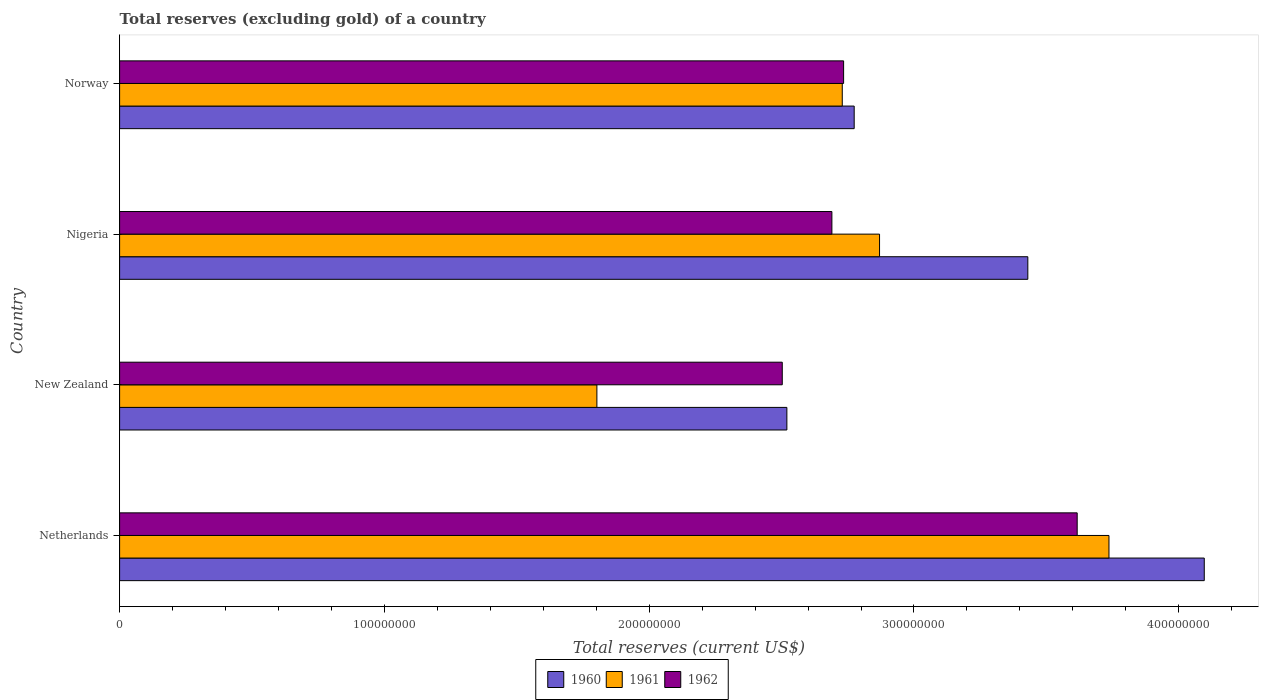How many different coloured bars are there?
Provide a short and direct response. 3. Are the number of bars per tick equal to the number of legend labels?
Ensure brevity in your answer.  Yes. How many bars are there on the 1st tick from the top?
Your response must be concise. 3. What is the label of the 3rd group of bars from the top?
Offer a terse response. New Zealand. In how many cases, is the number of bars for a given country not equal to the number of legend labels?
Make the answer very short. 0. What is the total reserves (excluding gold) in 1960 in New Zealand?
Ensure brevity in your answer.  2.52e+08. Across all countries, what is the maximum total reserves (excluding gold) in 1961?
Provide a short and direct response. 3.74e+08. Across all countries, what is the minimum total reserves (excluding gold) in 1960?
Your answer should be compact. 2.52e+08. In which country was the total reserves (excluding gold) in 1962 maximum?
Your response must be concise. Netherlands. In which country was the total reserves (excluding gold) in 1960 minimum?
Give a very brief answer. New Zealand. What is the total total reserves (excluding gold) in 1960 in the graph?
Your answer should be very brief. 1.28e+09. What is the difference between the total reserves (excluding gold) in 1962 in Netherlands and that in Norway?
Give a very brief answer. 8.82e+07. What is the difference between the total reserves (excluding gold) in 1961 in New Zealand and the total reserves (excluding gold) in 1962 in Netherlands?
Ensure brevity in your answer.  -1.81e+08. What is the average total reserves (excluding gold) in 1960 per country?
Provide a succinct answer. 3.21e+08. What is the difference between the total reserves (excluding gold) in 1960 and total reserves (excluding gold) in 1962 in Norway?
Make the answer very short. 3.99e+06. In how many countries, is the total reserves (excluding gold) in 1962 greater than 360000000 US$?
Your response must be concise. 1. What is the ratio of the total reserves (excluding gold) in 1961 in Netherlands to that in Norway?
Give a very brief answer. 1.37. Is the total reserves (excluding gold) in 1961 in Nigeria less than that in Norway?
Your answer should be very brief. No. Is the difference between the total reserves (excluding gold) in 1960 in Nigeria and Norway greater than the difference between the total reserves (excluding gold) in 1962 in Nigeria and Norway?
Make the answer very short. Yes. What is the difference between the highest and the second highest total reserves (excluding gold) in 1960?
Offer a very short reply. 6.66e+07. What is the difference between the highest and the lowest total reserves (excluding gold) in 1961?
Provide a succinct answer. 1.93e+08. How many countries are there in the graph?
Provide a short and direct response. 4. Are the values on the major ticks of X-axis written in scientific E-notation?
Give a very brief answer. No. Where does the legend appear in the graph?
Your answer should be very brief. Bottom center. How many legend labels are there?
Provide a succinct answer. 3. What is the title of the graph?
Your response must be concise. Total reserves (excluding gold) of a country. Does "2002" appear as one of the legend labels in the graph?
Give a very brief answer. No. What is the label or title of the X-axis?
Provide a succinct answer. Total reserves (current US$). What is the Total reserves (current US$) of 1960 in Netherlands?
Your answer should be very brief. 4.10e+08. What is the Total reserves (current US$) of 1961 in Netherlands?
Provide a succinct answer. 3.74e+08. What is the Total reserves (current US$) of 1962 in Netherlands?
Provide a short and direct response. 3.62e+08. What is the Total reserves (current US$) in 1960 in New Zealand?
Give a very brief answer. 2.52e+08. What is the Total reserves (current US$) of 1961 in New Zealand?
Keep it short and to the point. 1.80e+08. What is the Total reserves (current US$) of 1962 in New Zealand?
Ensure brevity in your answer.  2.50e+08. What is the Total reserves (current US$) of 1960 in Nigeria?
Your answer should be very brief. 3.43e+08. What is the Total reserves (current US$) of 1961 in Nigeria?
Offer a very short reply. 2.87e+08. What is the Total reserves (current US$) of 1962 in Nigeria?
Your response must be concise. 2.69e+08. What is the Total reserves (current US$) in 1960 in Norway?
Your answer should be compact. 2.77e+08. What is the Total reserves (current US$) of 1961 in Norway?
Offer a terse response. 2.73e+08. What is the Total reserves (current US$) of 1962 in Norway?
Provide a short and direct response. 2.73e+08. Across all countries, what is the maximum Total reserves (current US$) of 1960?
Offer a very short reply. 4.10e+08. Across all countries, what is the maximum Total reserves (current US$) in 1961?
Provide a succinct answer. 3.74e+08. Across all countries, what is the maximum Total reserves (current US$) of 1962?
Keep it short and to the point. 3.62e+08. Across all countries, what is the minimum Total reserves (current US$) in 1960?
Your answer should be compact. 2.52e+08. Across all countries, what is the minimum Total reserves (current US$) of 1961?
Make the answer very short. 1.80e+08. Across all countries, what is the minimum Total reserves (current US$) of 1962?
Ensure brevity in your answer.  2.50e+08. What is the total Total reserves (current US$) of 1960 in the graph?
Provide a short and direct response. 1.28e+09. What is the total Total reserves (current US$) of 1961 in the graph?
Your response must be concise. 1.11e+09. What is the total Total reserves (current US$) of 1962 in the graph?
Make the answer very short. 1.15e+09. What is the difference between the Total reserves (current US$) in 1960 in Netherlands and that in New Zealand?
Make the answer very short. 1.58e+08. What is the difference between the Total reserves (current US$) in 1961 in Netherlands and that in New Zealand?
Keep it short and to the point. 1.93e+08. What is the difference between the Total reserves (current US$) of 1962 in Netherlands and that in New Zealand?
Ensure brevity in your answer.  1.11e+08. What is the difference between the Total reserves (current US$) of 1960 in Netherlands and that in Nigeria?
Offer a terse response. 6.66e+07. What is the difference between the Total reserves (current US$) in 1961 in Netherlands and that in Nigeria?
Keep it short and to the point. 8.66e+07. What is the difference between the Total reserves (current US$) of 1962 in Netherlands and that in Nigeria?
Your answer should be compact. 9.26e+07. What is the difference between the Total reserves (current US$) in 1960 in Netherlands and that in Norway?
Your response must be concise. 1.32e+08. What is the difference between the Total reserves (current US$) in 1961 in Netherlands and that in Norway?
Make the answer very short. 1.01e+08. What is the difference between the Total reserves (current US$) of 1962 in Netherlands and that in Norway?
Your answer should be compact. 8.82e+07. What is the difference between the Total reserves (current US$) of 1960 in New Zealand and that in Nigeria?
Your answer should be compact. -9.10e+07. What is the difference between the Total reserves (current US$) of 1961 in New Zealand and that in Nigeria?
Provide a short and direct response. -1.07e+08. What is the difference between the Total reserves (current US$) in 1962 in New Zealand and that in Nigeria?
Offer a terse response. -1.87e+07. What is the difference between the Total reserves (current US$) of 1960 in New Zealand and that in Norway?
Offer a terse response. -2.54e+07. What is the difference between the Total reserves (current US$) of 1961 in New Zealand and that in Norway?
Provide a short and direct response. -9.27e+07. What is the difference between the Total reserves (current US$) in 1962 in New Zealand and that in Norway?
Your answer should be compact. -2.32e+07. What is the difference between the Total reserves (current US$) of 1960 in Nigeria and that in Norway?
Your response must be concise. 6.56e+07. What is the difference between the Total reserves (current US$) of 1961 in Nigeria and that in Norway?
Make the answer very short. 1.41e+07. What is the difference between the Total reserves (current US$) of 1962 in Nigeria and that in Norway?
Your answer should be compact. -4.43e+06. What is the difference between the Total reserves (current US$) of 1960 in Netherlands and the Total reserves (current US$) of 1961 in New Zealand?
Give a very brief answer. 2.29e+08. What is the difference between the Total reserves (current US$) of 1960 in Netherlands and the Total reserves (current US$) of 1962 in New Zealand?
Your response must be concise. 1.59e+08. What is the difference between the Total reserves (current US$) of 1961 in Netherlands and the Total reserves (current US$) of 1962 in New Zealand?
Make the answer very short. 1.23e+08. What is the difference between the Total reserves (current US$) of 1960 in Netherlands and the Total reserves (current US$) of 1961 in Nigeria?
Your answer should be very brief. 1.23e+08. What is the difference between the Total reserves (current US$) in 1960 in Netherlands and the Total reserves (current US$) in 1962 in Nigeria?
Keep it short and to the point. 1.41e+08. What is the difference between the Total reserves (current US$) in 1961 in Netherlands and the Total reserves (current US$) in 1962 in Nigeria?
Your response must be concise. 1.05e+08. What is the difference between the Total reserves (current US$) in 1960 in Netherlands and the Total reserves (current US$) in 1961 in Norway?
Provide a succinct answer. 1.37e+08. What is the difference between the Total reserves (current US$) of 1960 in Netherlands and the Total reserves (current US$) of 1962 in Norway?
Give a very brief answer. 1.36e+08. What is the difference between the Total reserves (current US$) in 1961 in Netherlands and the Total reserves (current US$) in 1962 in Norway?
Offer a terse response. 1.00e+08. What is the difference between the Total reserves (current US$) in 1960 in New Zealand and the Total reserves (current US$) in 1961 in Nigeria?
Ensure brevity in your answer.  -3.50e+07. What is the difference between the Total reserves (current US$) in 1960 in New Zealand and the Total reserves (current US$) in 1962 in Nigeria?
Offer a very short reply. -1.70e+07. What is the difference between the Total reserves (current US$) in 1961 in New Zealand and the Total reserves (current US$) in 1962 in Nigeria?
Make the answer very short. -8.88e+07. What is the difference between the Total reserves (current US$) in 1960 in New Zealand and the Total reserves (current US$) in 1961 in Norway?
Your response must be concise. -2.09e+07. What is the difference between the Total reserves (current US$) of 1960 in New Zealand and the Total reserves (current US$) of 1962 in Norway?
Provide a short and direct response. -2.14e+07. What is the difference between the Total reserves (current US$) of 1961 in New Zealand and the Total reserves (current US$) of 1962 in Norway?
Offer a terse response. -9.32e+07. What is the difference between the Total reserves (current US$) of 1960 in Nigeria and the Total reserves (current US$) of 1961 in Norway?
Make the answer very short. 7.01e+07. What is the difference between the Total reserves (current US$) of 1960 in Nigeria and the Total reserves (current US$) of 1962 in Norway?
Make the answer very short. 6.96e+07. What is the difference between the Total reserves (current US$) in 1961 in Nigeria and the Total reserves (current US$) in 1962 in Norway?
Your answer should be very brief. 1.36e+07. What is the average Total reserves (current US$) in 1960 per country?
Provide a succinct answer. 3.21e+08. What is the average Total reserves (current US$) of 1961 per country?
Keep it short and to the point. 2.78e+08. What is the average Total reserves (current US$) of 1962 per country?
Provide a short and direct response. 2.89e+08. What is the difference between the Total reserves (current US$) in 1960 and Total reserves (current US$) in 1961 in Netherlands?
Provide a succinct answer. 3.60e+07. What is the difference between the Total reserves (current US$) of 1960 and Total reserves (current US$) of 1962 in Netherlands?
Offer a very short reply. 4.80e+07. What is the difference between the Total reserves (current US$) in 1961 and Total reserves (current US$) in 1962 in Netherlands?
Offer a very short reply. 1.20e+07. What is the difference between the Total reserves (current US$) in 1960 and Total reserves (current US$) in 1961 in New Zealand?
Offer a very short reply. 7.18e+07. What is the difference between the Total reserves (current US$) of 1960 and Total reserves (current US$) of 1962 in New Zealand?
Provide a succinct answer. 1.74e+06. What is the difference between the Total reserves (current US$) in 1961 and Total reserves (current US$) in 1962 in New Zealand?
Provide a short and direct response. -7.00e+07. What is the difference between the Total reserves (current US$) of 1960 and Total reserves (current US$) of 1961 in Nigeria?
Your answer should be compact. 5.60e+07. What is the difference between the Total reserves (current US$) of 1960 and Total reserves (current US$) of 1962 in Nigeria?
Make the answer very short. 7.40e+07. What is the difference between the Total reserves (current US$) of 1961 and Total reserves (current US$) of 1962 in Nigeria?
Make the answer very short. 1.80e+07. What is the difference between the Total reserves (current US$) in 1960 and Total reserves (current US$) in 1961 in Norway?
Offer a terse response. 4.50e+06. What is the difference between the Total reserves (current US$) of 1960 and Total reserves (current US$) of 1962 in Norway?
Provide a short and direct response. 3.99e+06. What is the difference between the Total reserves (current US$) in 1961 and Total reserves (current US$) in 1962 in Norway?
Give a very brief answer. -5.10e+05. What is the ratio of the Total reserves (current US$) in 1960 in Netherlands to that in New Zealand?
Provide a succinct answer. 1.63. What is the ratio of the Total reserves (current US$) in 1961 in Netherlands to that in New Zealand?
Your answer should be very brief. 2.07. What is the ratio of the Total reserves (current US$) in 1962 in Netherlands to that in New Zealand?
Your response must be concise. 1.45. What is the ratio of the Total reserves (current US$) of 1960 in Netherlands to that in Nigeria?
Offer a terse response. 1.19. What is the ratio of the Total reserves (current US$) in 1961 in Netherlands to that in Nigeria?
Your answer should be compact. 1.3. What is the ratio of the Total reserves (current US$) of 1962 in Netherlands to that in Nigeria?
Your answer should be compact. 1.34. What is the ratio of the Total reserves (current US$) of 1960 in Netherlands to that in Norway?
Your answer should be compact. 1.48. What is the ratio of the Total reserves (current US$) in 1961 in Netherlands to that in Norway?
Ensure brevity in your answer.  1.37. What is the ratio of the Total reserves (current US$) of 1962 in Netherlands to that in Norway?
Your answer should be very brief. 1.32. What is the ratio of the Total reserves (current US$) of 1960 in New Zealand to that in Nigeria?
Keep it short and to the point. 0.73. What is the ratio of the Total reserves (current US$) in 1961 in New Zealand to that in Nigeria?
Ensure brevity in your answer.  0.63. What is the ratio of the Total reserves (current US$) of 1962 in New Zealand to that in Nigeria?
Give a very brief answer. 0.93. What is the ratio of the Total reserves (current US$) in 1960 in New Zealand to that in Norway?
Provide a succinct answer. 0.91. What is the ratio of the Total reserves (current US$) of 1961 in New Zealand to that in Norway?
Ensure brevity in your answer.  0.66. What is the ratio of the Total reserves (current US$) in 1962 in New Zealand to that in Norway?
Your answer should be very brief. 0.92. What is the ratio of the Total reserves (current US$) in 1960 in Nigeria to that in Norway?
Ensure brevity in your answer.  1.24. What is the ratio of the Total reserves (current US$) of 1961 in Nigeria to that in Norway?
Your answer should be very brief. 1.05. What is the ratio of the Total reserves (current US$) in 1962 in Nigeria to that in Norway?
Your answer should be compact. 0.98. What is the difference between the highest and the second highest Total reserves (current US$) in 1960?
Your answer should be very brief. 6.66e+07. What is the difference between the highest and the second highest Total reserves (current US$) in 1961?
Your answer should be compact. 8.66e+07. What is the difference between the highest and the second highest Total reserves (current US$) in 1962?
Ensure brevity in your answer.  8.82e+07. What is the difference between the highest and the lowest Total reserves (current US$) in 1960?
Offer a terse response. 1.58e+08. What is the difference between the highest and the lowest Total reserves (current US$) of 1961?
Your answer should be very brief. 1.93e+08. What is the difference between the highest and the lowest Total reserves (current US$) in 1962?
Ensure brevity in your answer.  1.11e+08. 